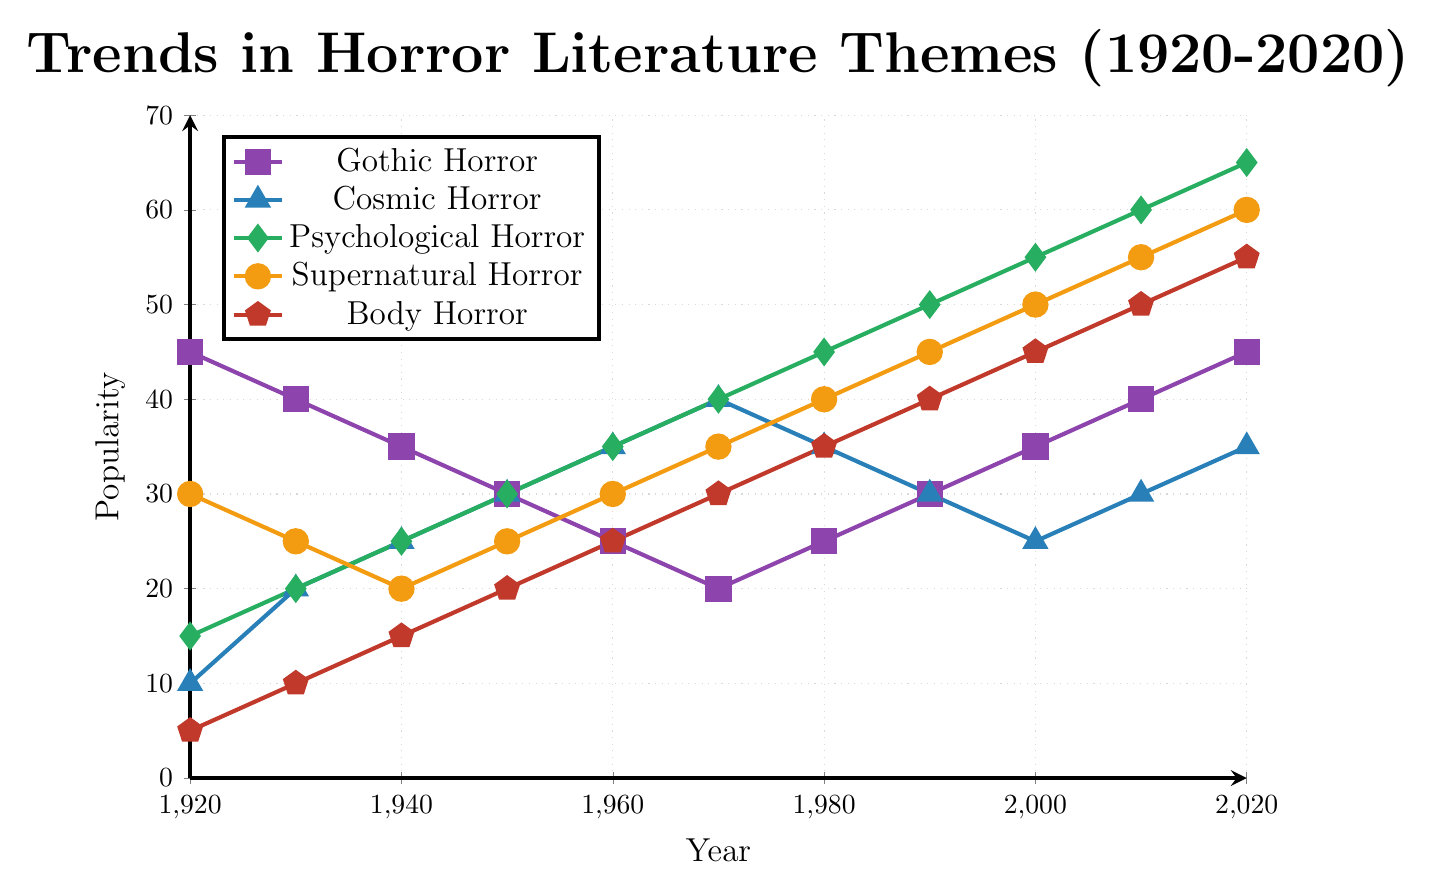What subgenre of horror has experienced the most significant increase in popularity over the last century? From the figure, Psychological Horror has increased from 15 in 1920 to 65 in 2020, which is an increase of 50 points, the largest among all subgenres.
Answer: Psychological Horror In which decade did Gothic Horror reach its lowest popularity? According to the figure, Gothic Horror reached its lowest popularity in the 1970s with a value of 20.
Answer: 1970s How many different subgenres reached a popularity value of at least 50 by 2020? By 2020, the subgenres that reached at least 50 are Psychological Horror, Supernatural Horror, and Body Horror, which are three subgenres.
Answer: 3 In 1960, which horror subgenre was least popular? From the figure, the least popular subgenre in 1960 was Body Horror with a popularity value of 25.
Answer: Body Horror Compare the popularity trends of Cosmic Horror and Supernatural Horror from 1920 to 2020. Which one has more fluctuations? Supernatural Horror fluctuates between 20 and 60, while Cosmic Horror fluctuates between 10 and 40. The swings of Supernatural Horror are more notable, indicating more fluctuations.
Answer: Supernatural Horror What is the difference in popularity between Body Horror and Gothic Horror in 2020? In 2020, Body Horror has a popularity value of 55, and Gothic Horror has a value of 45. The difference is 55 - 45 = 10.
Answer: 10 What was the popularity trend of Psychological Horror between 1970 and 2000, and how does it compare to the trend of Supernatural Horror in the same period? Psychological Horror increased from 40 to 55, a steady rise of 15 points, while Supernatural Horror increased from 35 to 50, an increase of 15 points, showing similar trends for both subgenres.
Answer: Steady rise, similar trends Which subgenre saw an increase in popularity every decade without any decline? From 1920 to 2020, Psychological Horror has consistently increased every decade without any decline.
Answer: Psychological Horror 